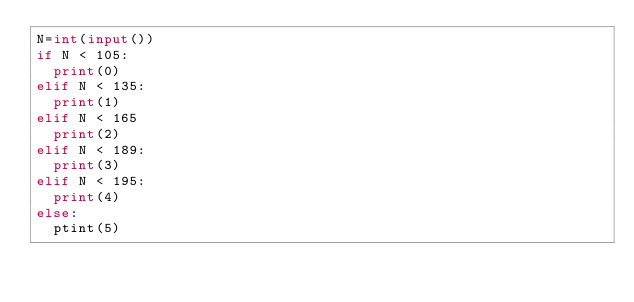<code> <loc_0><loc_0><loc_500><loc_500><_Python_>N=int(input())
if N < 105:
  print(0)
elif N < 135:
  print(1)
elif N < 165
  print(2)
elif N < 189:
  print(3)
elif N < 195:
  print(4)
else:
  ptint(5)</code> 